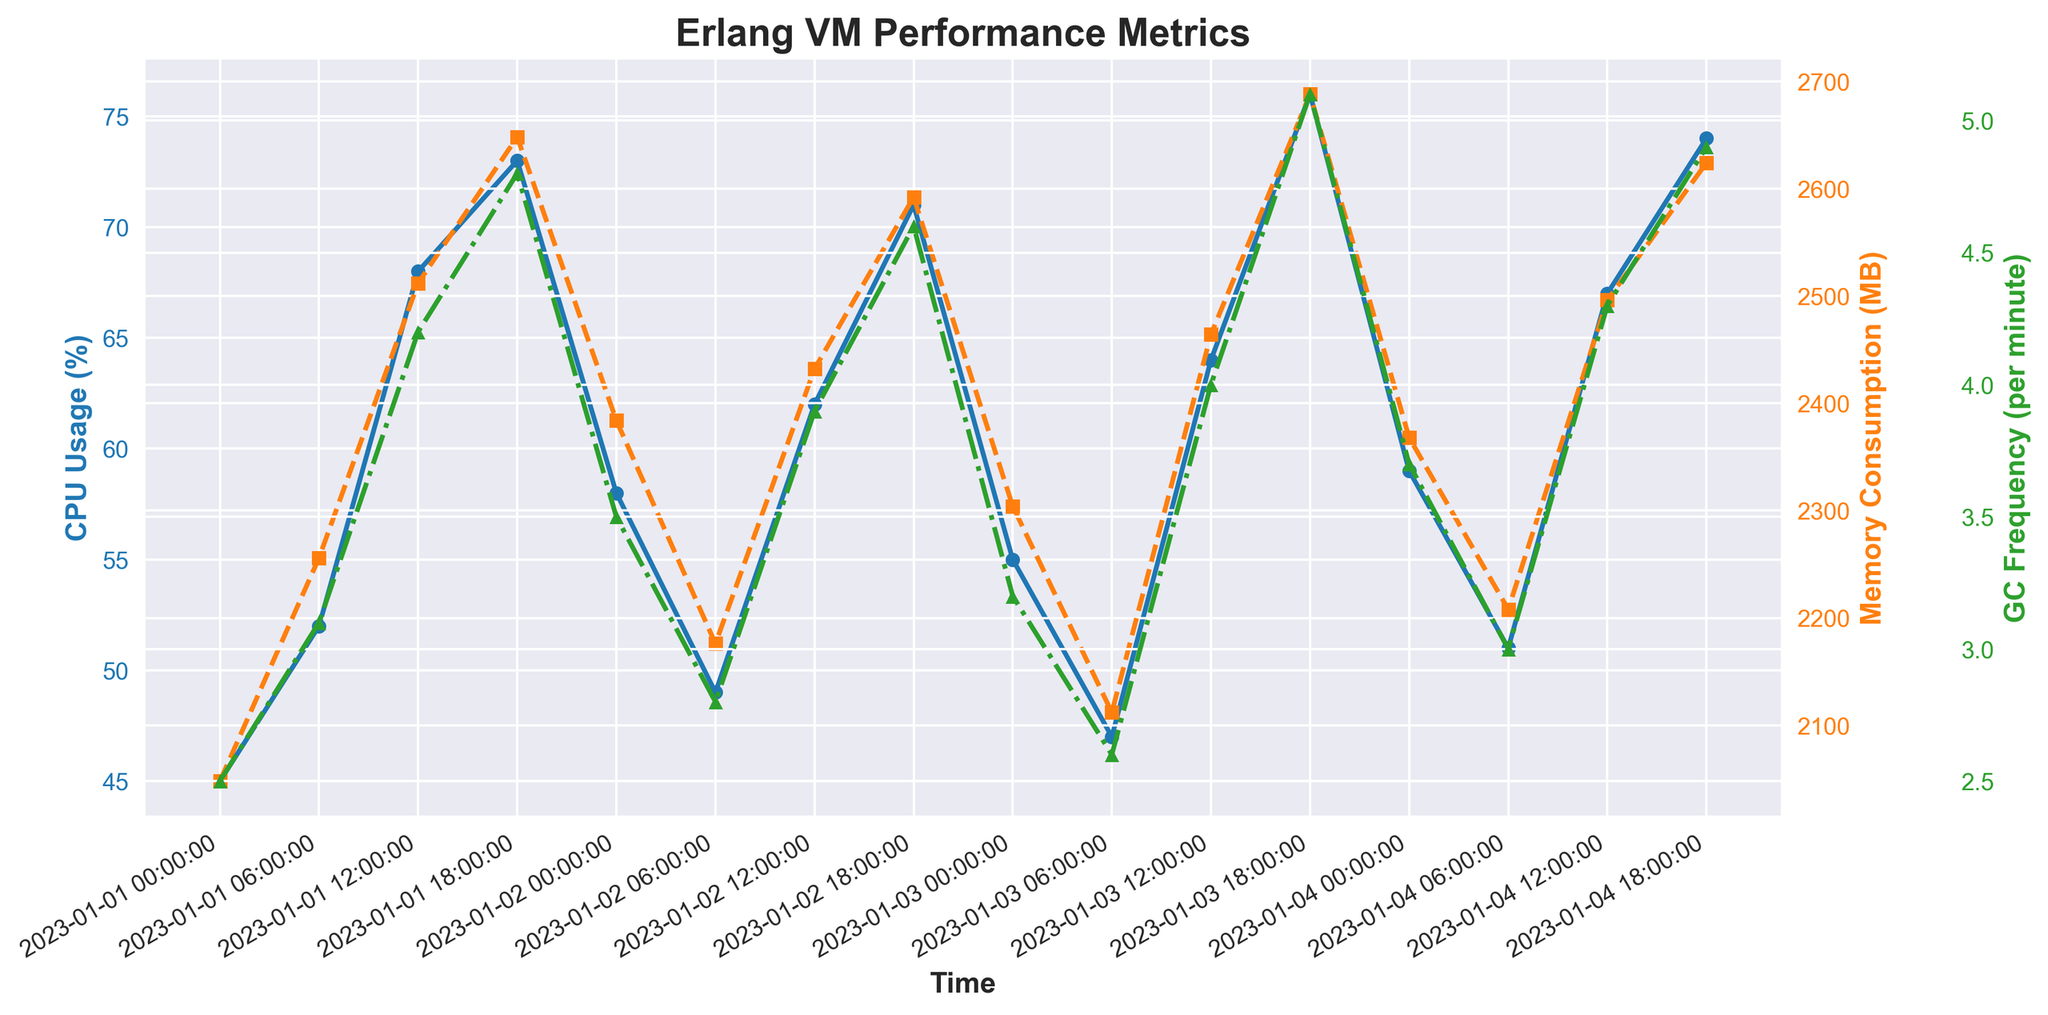What's the overall trend in CPU usage from January 1 to January 4? Observe the 'CPU Usage (%)' line. It increases from 45% to 74%, with periodic dips and rises along the way.
Answer: Increasing During which time period does memory consumption peak? Look at the 'Memory Consumption (MB)' plot, find the peak value, and note the corresponding time. The highest point is 2688MB at 2023-01-03 18:00:00.
Answer: 2023-01-03 18:00:00 Which time period shows the highest garbage collection frequency? Examine the 'GC Frequency (per minute)' line and find the peak value, which is 5.1 at 2023-01-03 18:00:00.
Answer: 2023-01-03 18:00:00 Compare CPU usage at 2023-01-02 06:00:00 and 2023-01-04 06:00:00. Which is higher and by how much? The CPU usages are 49% and 51% respectively. The difference is 51% - 49% = 2%.
Answer: 2023-01-04 06:00:00 by 2% What is the average memory consumption over the 4 days? Summing the 'Memory Consumption (MB)' values (2048 + 2256 + 2512 + 2648 + 2384 + 2176 + 2432 + 2592 + 2304 + 2112 + 2464 + 2688 + 2368 + 2208 + 2496 + 2624) = 39808. There are 16 data points. Average = 39808 / 16 = 2488MB.
Answer: 2488MB From January 1 to January 4, which metric shows the most noticeable fluctuations? The GC Frequency line shows frequent up and down patterns with variations between 2.5 and 5.1, the other metrics show steadier trends.
Answer: GC Frequency At what time is the CPU usage equal to 68%? Locate 68% on the 'CPU Usage (%)' line. It corresponds to 2023-01-01 12:00:00.
Answer: 2023-01-01 12:00:00 Does a high memory consumption correlate with high CPU usage? Provide an example. Compare spikes in both lines. For instance, at 2023-01-03 18:00:00, memory consumption is 2688MB and CPU usage is 76%, indicating a possible correlation.
Answer: Yes, e.g., 2023-01-03 18:00:00 Between which time periods does the memory consumption increase the most rapidly? The steepest slope on the memory consumption line is between 2023-01-02 12:00:00 and 2023-01-03 18:00:00 where it rises from 2432MB to 2688MB.
Answer: 2023-01-02 12:00:00 to 2023-01-03 18:00:00 What is the average GC Frequency for the first and last 12-hour periods? For the first 12-hour period, (2.5 + 3.1) / 2 = 2.8. For the last 12-hour period, (4.3 + 4.9) / 2 = 4.6.
Answer: First period: 2.8, Last period: 4.6 